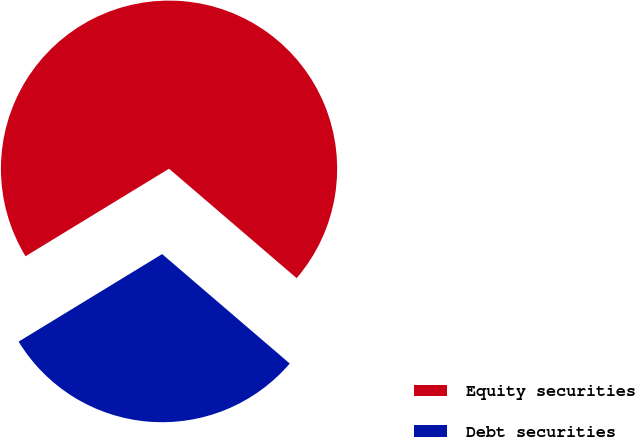Convert chart. <chart><loc_0><loc_0><loc_500><loc_500><pie_chart><fcel>Equity securities<fcel>Debt securities<nl><fcel>70.0%<fcel>30.0%<nl></chart> 